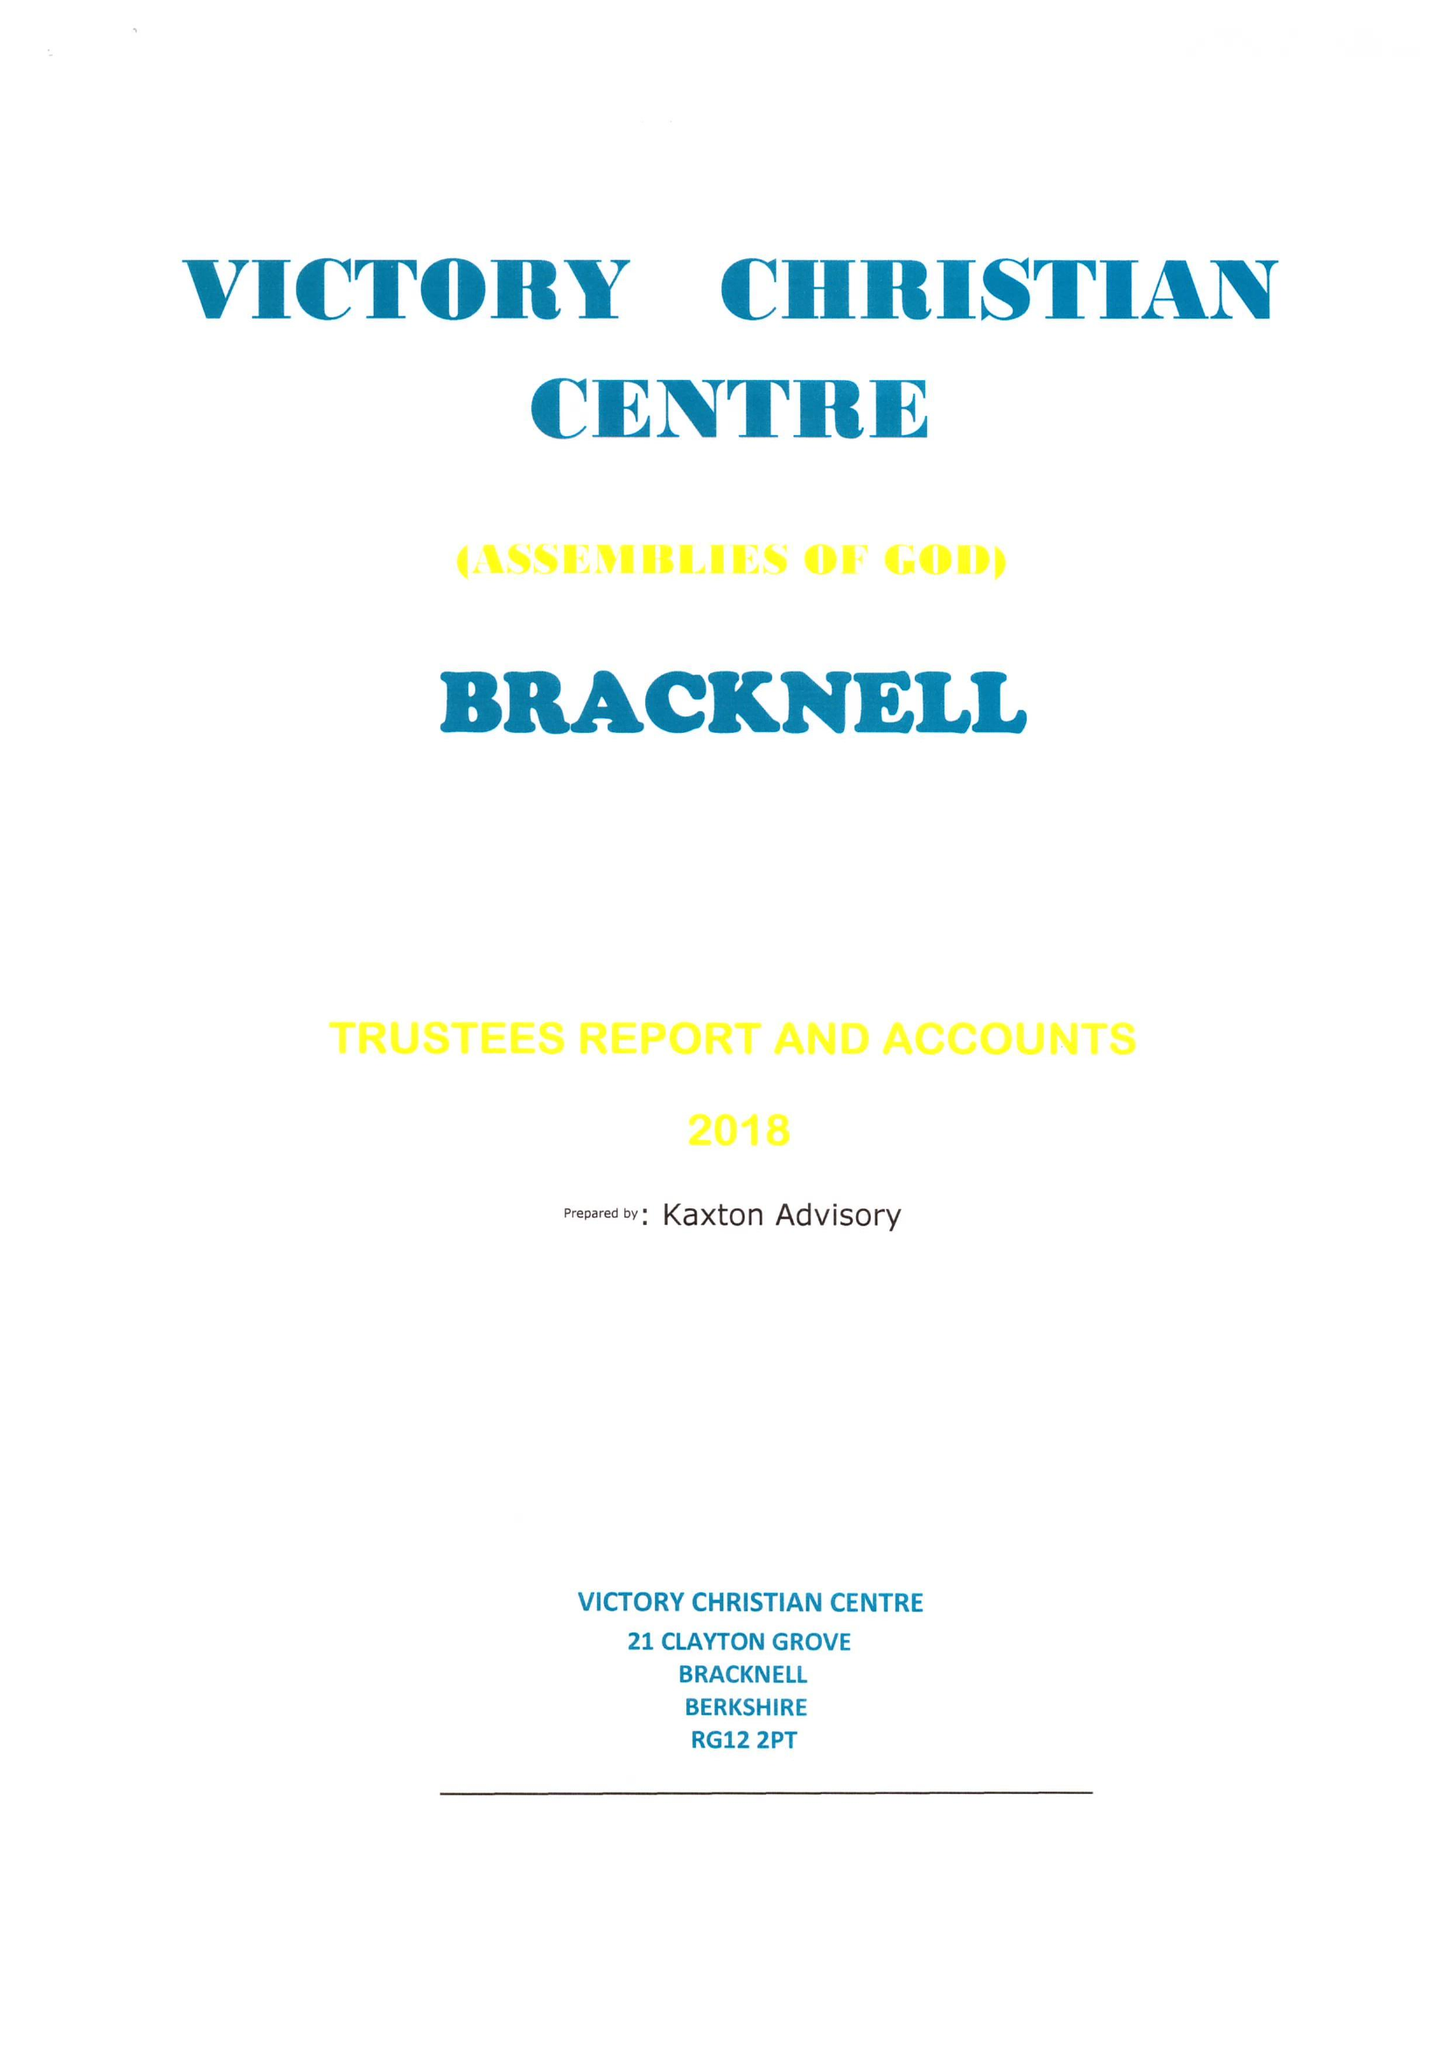What is the value for the address__post_town?
Answer the question using a single word or phrase. BRACKNELL 